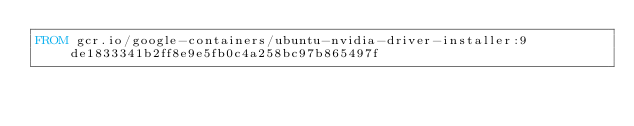<code> <loc_0><loc_0><loc_500><loc_500><_Dockerfile_>FROM gcr.io/google-containers/ubuntu-nvidia-driver-installer:9de1833341b2ff8e9e5fb0c4a258bc97b865497f
</code> 